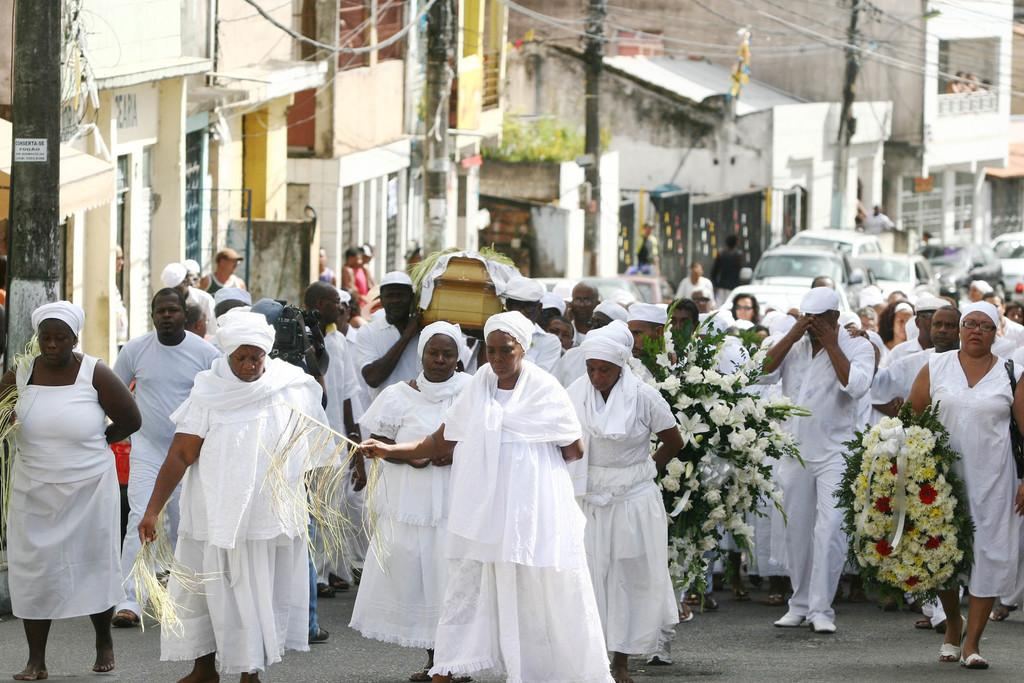Where was the image taken? The image was clicked outside. What is happening in the middle of the image? There are persons in the middle of the image, and some of them are holding flowers. What can be seen on the right side of the image? There are vehicles on the right side of the image. What type of structures are visible in the image? There are buildings in the middle of the image. What color is the sun in the image? There is no sun visible in the image. How does the tongue of the person in the image look? There are no visible tongues in the image. 